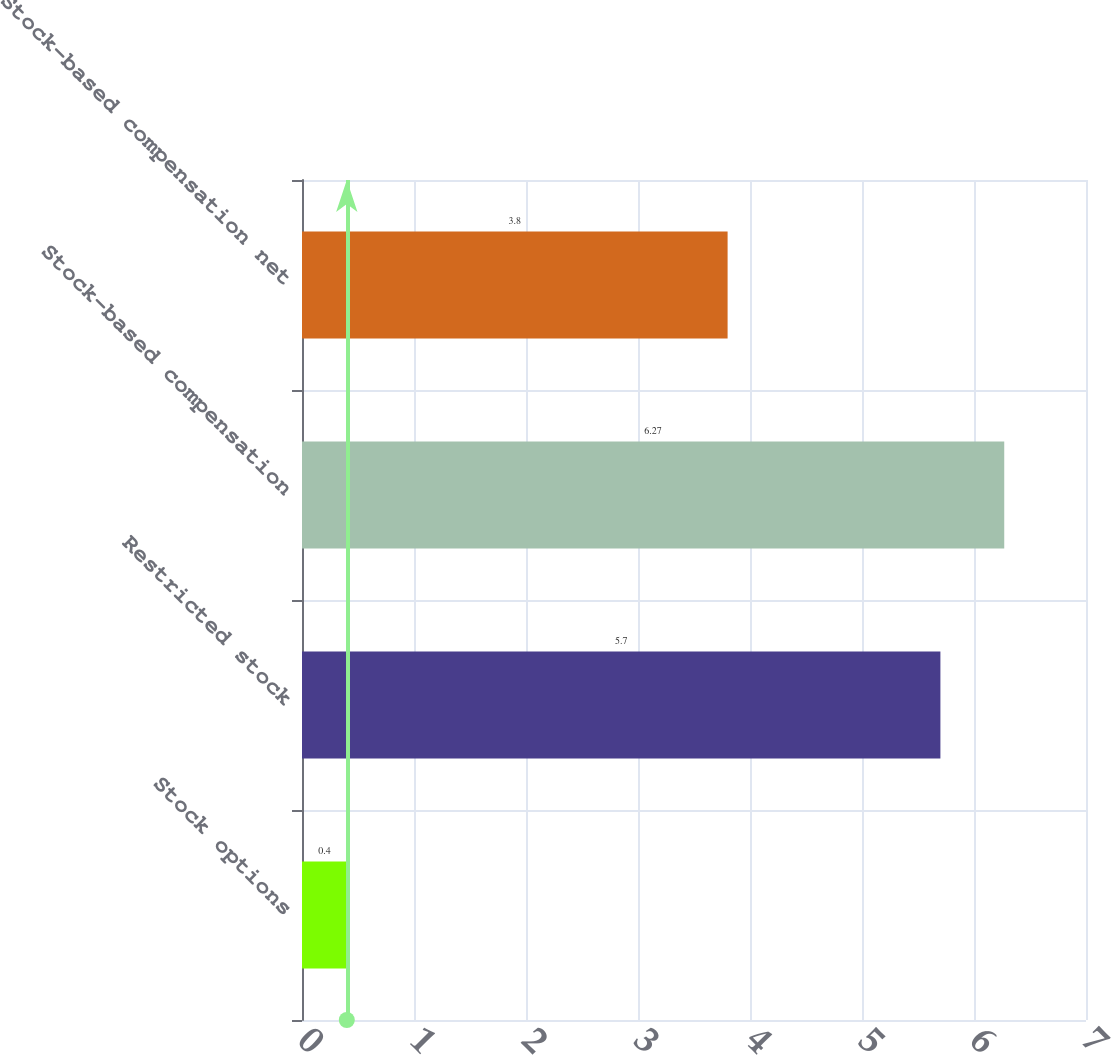Convert chart to OTSL. <chart><loc_0><loc_0><loc_500><loc_500><bar_chart><fcel>Stock options<fcel>Restricted stock<fcel>Stock-based compensation<fcel>Stock-based compensation net<nl><fcel>0.4<fcel>5.7<fcel>6.27<fcel>3.8<nl></chart> 